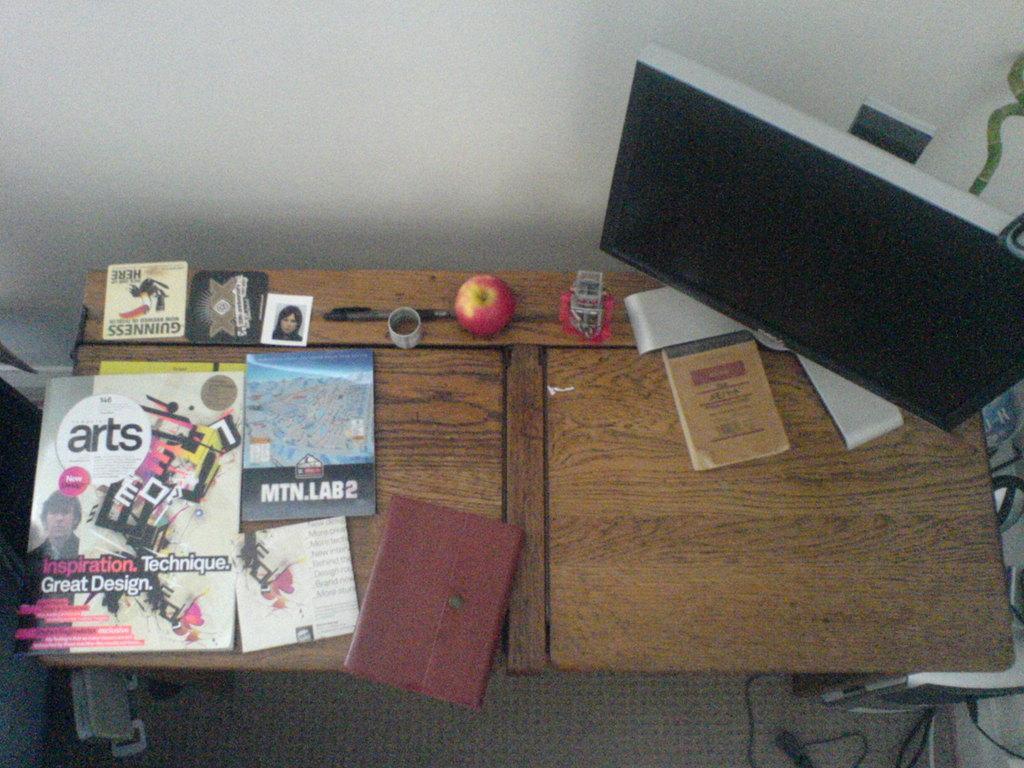Describe this image in one or two sentences. In the given image i can see a wooden table on which i can see books,pad,pen,photo,fruit,system,dairy and some other objects. 